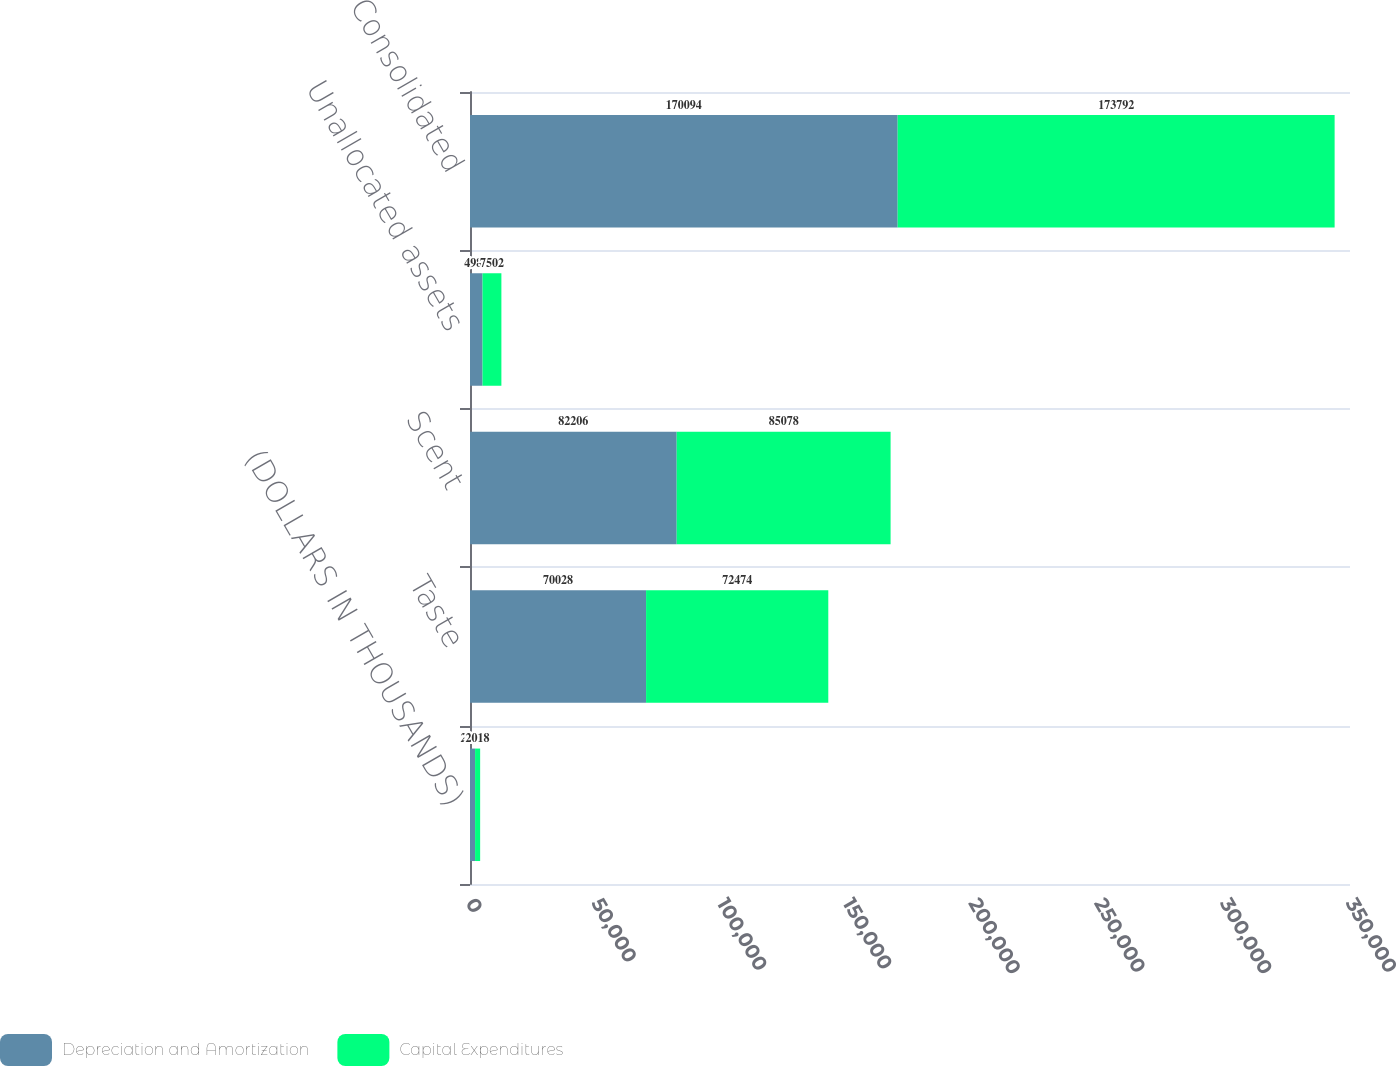Convert chart. <chart><loc_0><loc_0><loc_500><loc_500><stacked_bar_chart><ecel><fcel>(DOLLARS IN THOUSANDS)<fcel>Taste<fcel>Scent<fcel>Unallocated assets<fcel>Consolidated<nl><fcel>Depreciation and Amortization<fcel>2018<fcel>70028<fcel>82206<fcel>4982<fcel>170094<nl><fcel>Capital Expenditures<fcel>2018<fcel>72474<fcel>85078<fcel>7502<fcel>173792<nl></chart> 